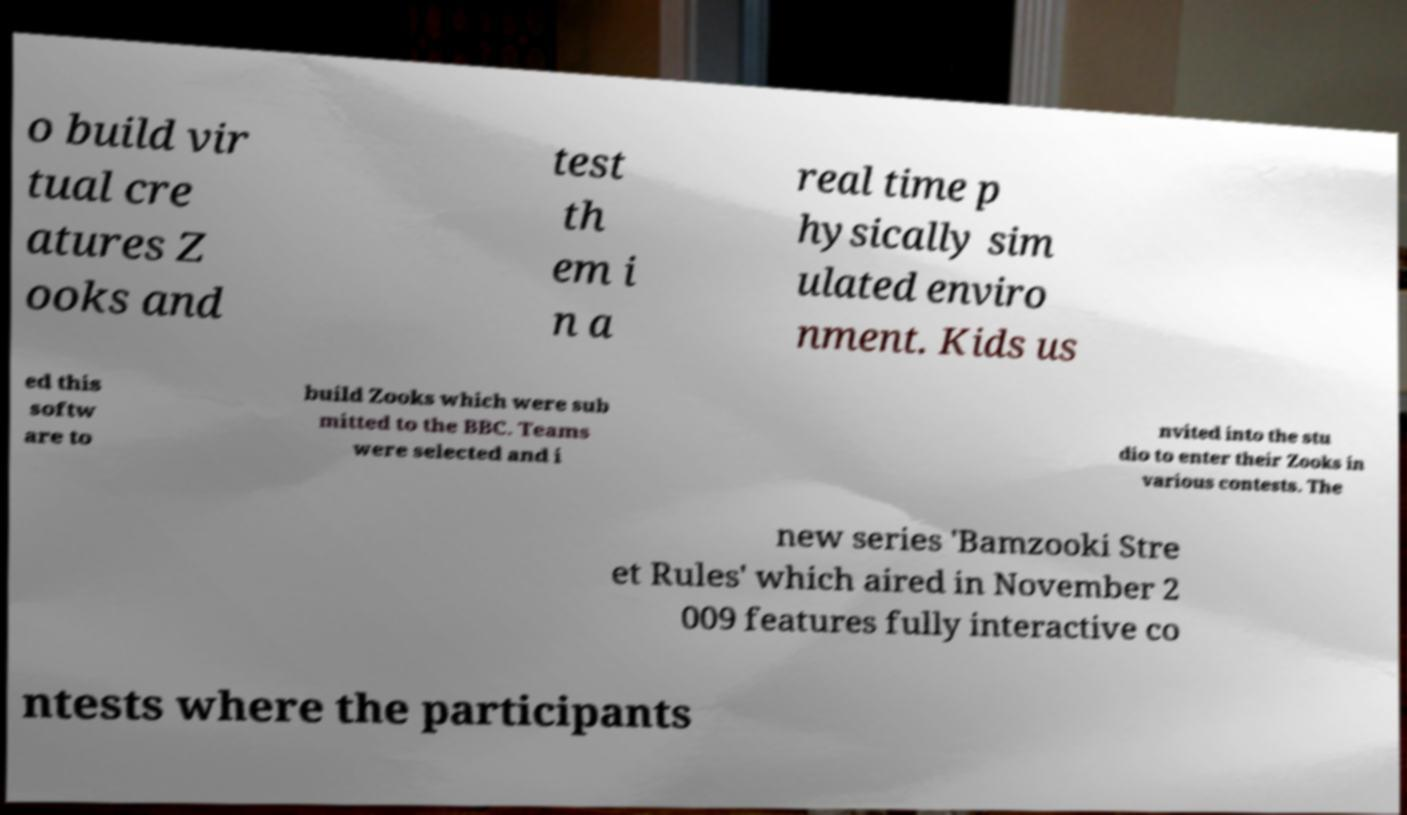What messages or text are displayed in this image? I need them in a readable, typed format. o build vir tual cre atures Z ooks and test th em i n a real time p hysically sim ulated enviro nment. Kids us ed this softw are to build Zooks which were sub mitted to the BBC. Teams were selected and i nvited into the stu dio to enter their Zooks in various contests. The new series 'Bamzooki Stre et Rules' which aired in November 2 009 features fully interactive co ntests where the participants 